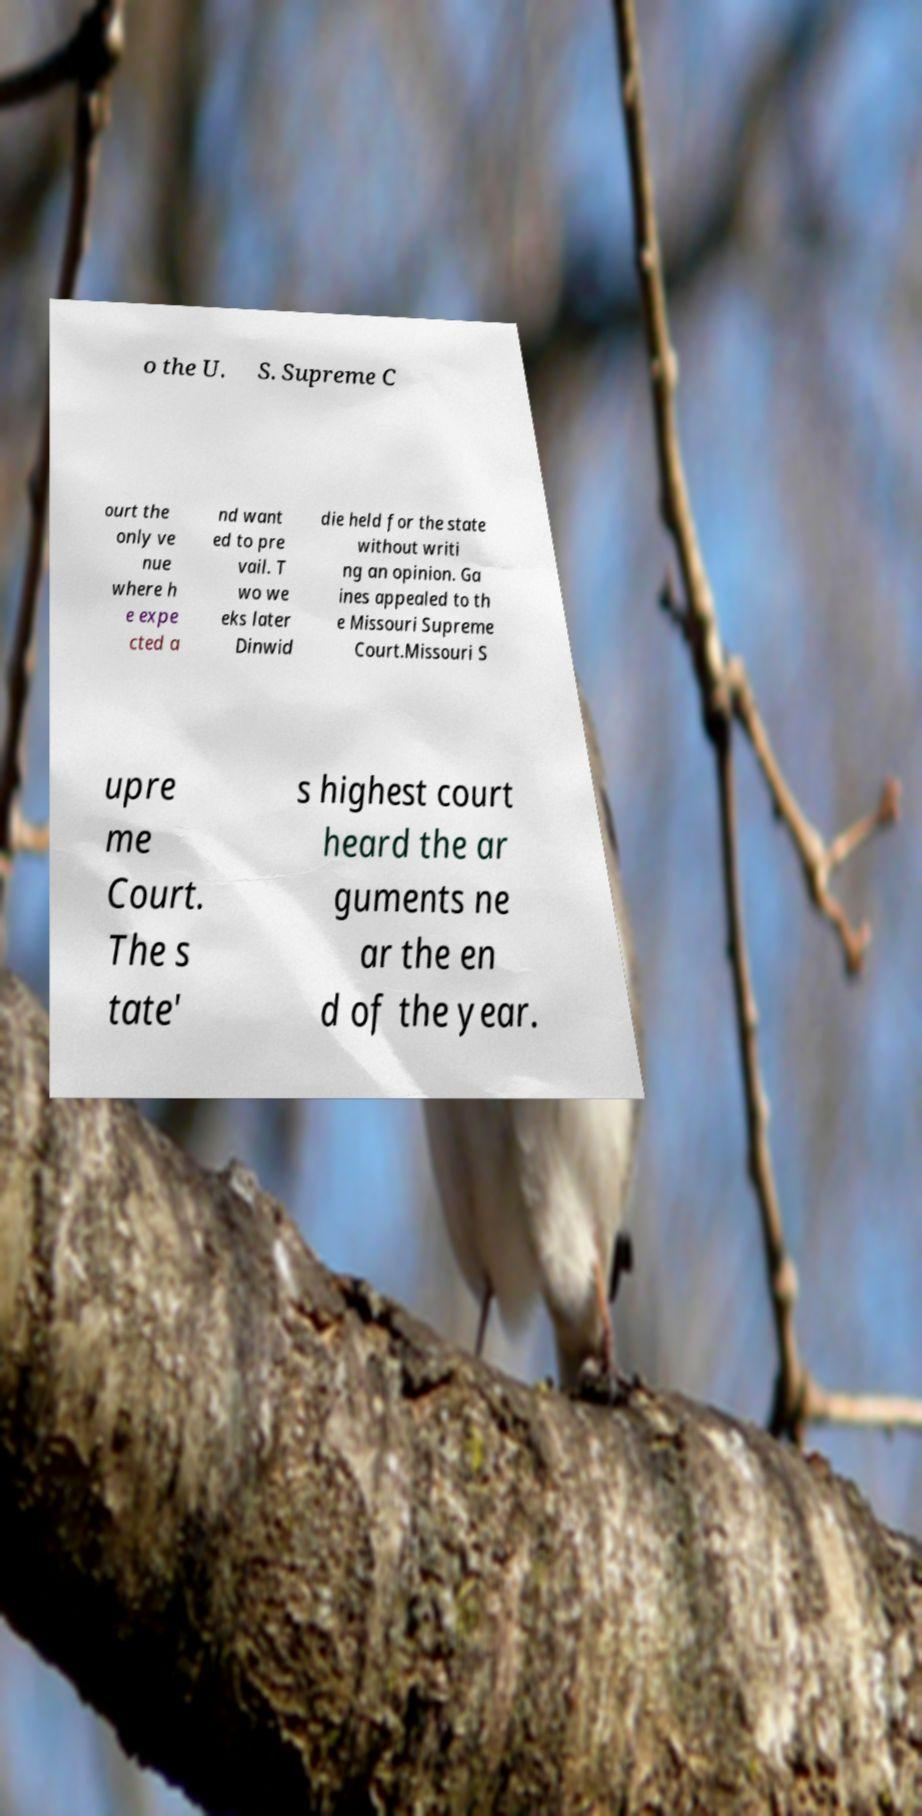I need the written content from this picture converted into text. Can you do that? o the U. S. Supreme C ourt the only ve nue where h e expe cted a nd want ed to pre vail. T wo we eks later Dinwid die held for the state without writi ng an opinion. Ga ines appealed to th e Missouri Supreme Court.Missouri S upre me Court. The s tate' s highest court heard the ar guments ne ar the en d of the year. 